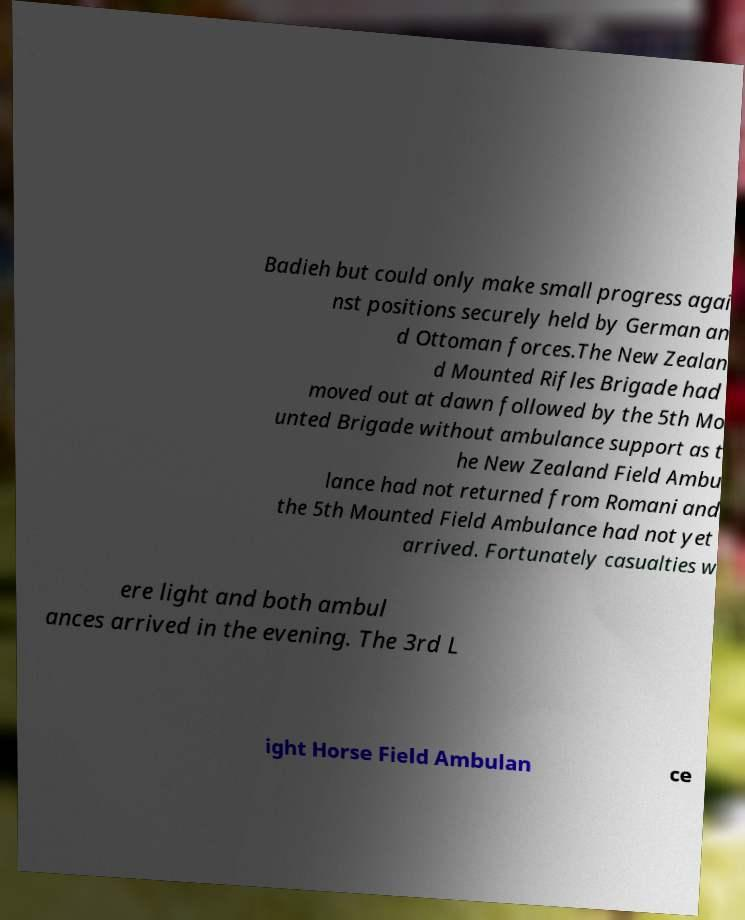What messages or text are displayed in this image? I need them in a readable, typed format. Badieh but could only make small progress agai nst positions securely held by German an d Ottoman forces.The New Zealan d Mounted Rifles Brigade had moved out at dawn followed by the 5th Mo unted Brigade without ambulance support as t he New Zealand Field Ambu lance had not returned from Romani and the 5th Mounted Field Ambulance had not yet arrived. Fortunately casualties w ere light and both ambul ances arrived in the evening. The 3rd L ight Horse Field Ambulan ce 